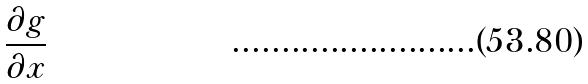Convert formula to latex. <formula><loc_0><loc_0><loc_500><loc_500>\frac { \partial g } { \partial x }</formula> 